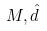Convert formula to latex. <formula><loc_0><loc_0><loc_500><loc_500>M , \hat { d }</formula> 